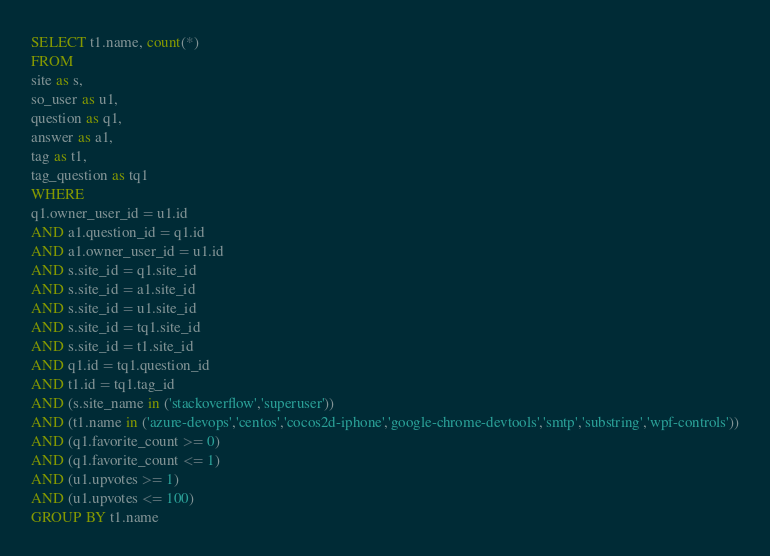Convert code to text. <code><loc_0><loc_0><loc_500><loc_500><_SQL_>SELECT t1.name, count(*)
FROM
site as s,
so_user as u1,
question as q1,
answer as a1,
tag as t1,
tag_question as tq1
WHERE
q1.owner_user_id = u1.id
AND a1.question_id = q1.id
AND a1.owner_user_id = u1.id
AND s.site_id = q1.site_id
AND s.site_id = a1.site_id
AND s.site_id = u1.site_id
AND s.site_id = tq1.site_id
AND s.site_id = t1.site_id
AND q1.id = tq1.question_id
AND t1.id = tq1.tag_id
AND (s.site_name in ('stackoverflow','superuser'))
AND (t1.name in ('azure-devops','centos','cocos2d-iphone','google-chrome-devtools','smtp','substring','wpf-controls'))
AND (q1.favorite_count >= 0)
AND (q1.favorite_count <= 1)
AND (u1.upvotes >= 1)
AND (u1.upvotes <= 100)
GROUP BY t1.name</code> 